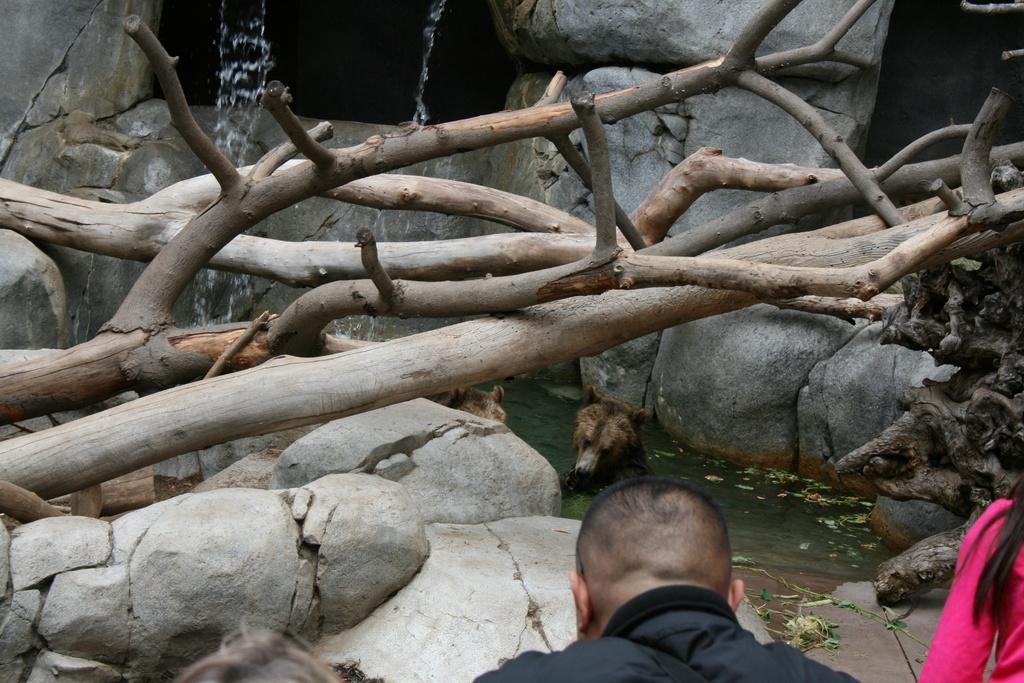Can you describe this image briefly? Here we can see wooden sticks. This is water and there is an animal. There are two persons. In the background we can see rocks. 